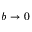<formula> <loc_0><loc_0><loc_500><loc_500>b \rightarrow 0</formula> 